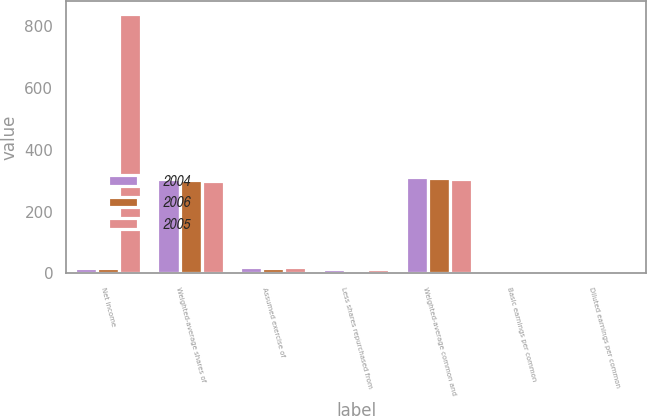Convert chart. <chart><loc_0><loc_0><loc_500><loc_500><stacked_bar_chart><ecel><fcel>Net income<fcel>Weighted-average shares of<fcel>Assumed exercise of<fcel>Less shares repurchased from<fcel>Weighted-average common and<fcel>Basic earnings per common<fcel>Diluted earnings per common<nl><fcel>2004<fcel>18<fcel>304<fcel>19<fcel>13<fcel>310<fcel>5.94<fcel>5.83<nl><fcel>2006<fcel>18<fcel>301<fcel>18<fcel>12<fcel>307<fcel>4.81<fcel>4.72<nl><fcel>2005<fcel>838<fcel>299<fcel>19<fcel>14<fcel>304<fcel>2.8<fcel>2.76<nl></chart> 